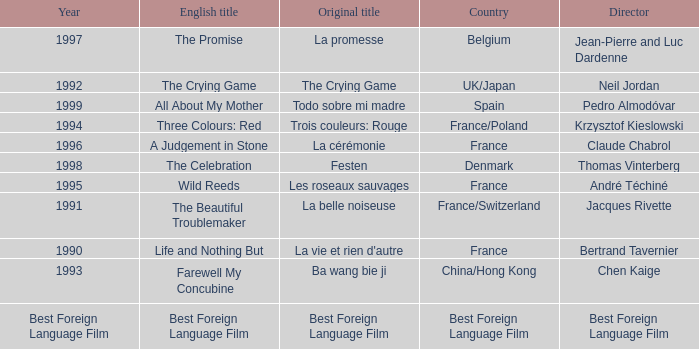Help me parse the entirety of this table. {'header': ['Year', 'English title', 'Original title', 'Country', 'Director'], 'rows': [['1997', 'The Promise', 'La promesse', 'Belgium', 'Jean-Pierre and Luc Dardenne'], ['1992', 'The Crying Game', 'The Crying Game', 'UK/Japan', 'Neil Jordan'], ['1999', 'All About My Mother', 'Todo sobre mi madre', 'Spain', 'Pedro Almodóvar'], ['1994', 'Three Colours: Red', 'Trois couleurs: Rouge', 'France/Poland', 'Krzysztof Kieslowski'], ['1996', 'A Judgement in Stone', 'La cérémonie', 'France', 'Claude Chabrol'], ['1998', 'The Celebration', 'Festen', 'Denmark', 'Thomas Vinterberg'], ['1995', 'Wild Reeds', 'Les roseaux sauvages', 'France', 'André Téchiné'], ['1991', 'The Beautiful Troublemaker', 'La belle noiseuse', 'France/Switzerland', 'Jacques Rivette'], ['1990', 'Life and Nothing But', "La vie et rien d'autre", 'France', 'Bertrand Tavernier'], ['1993', 'Farewell My Concubine', 'Ba wang bie ji', 'China/Hong Kong', 'Chen Kaige'], ['Best Foreign Language Film', 'Best Foreign Language Film', 'Best Foreign Language Film', 'Best Foreign Language Film', 'Best Foreign Language Film']]} Who is the Director of the Original title of The Crying Game? Neil Jordan. 